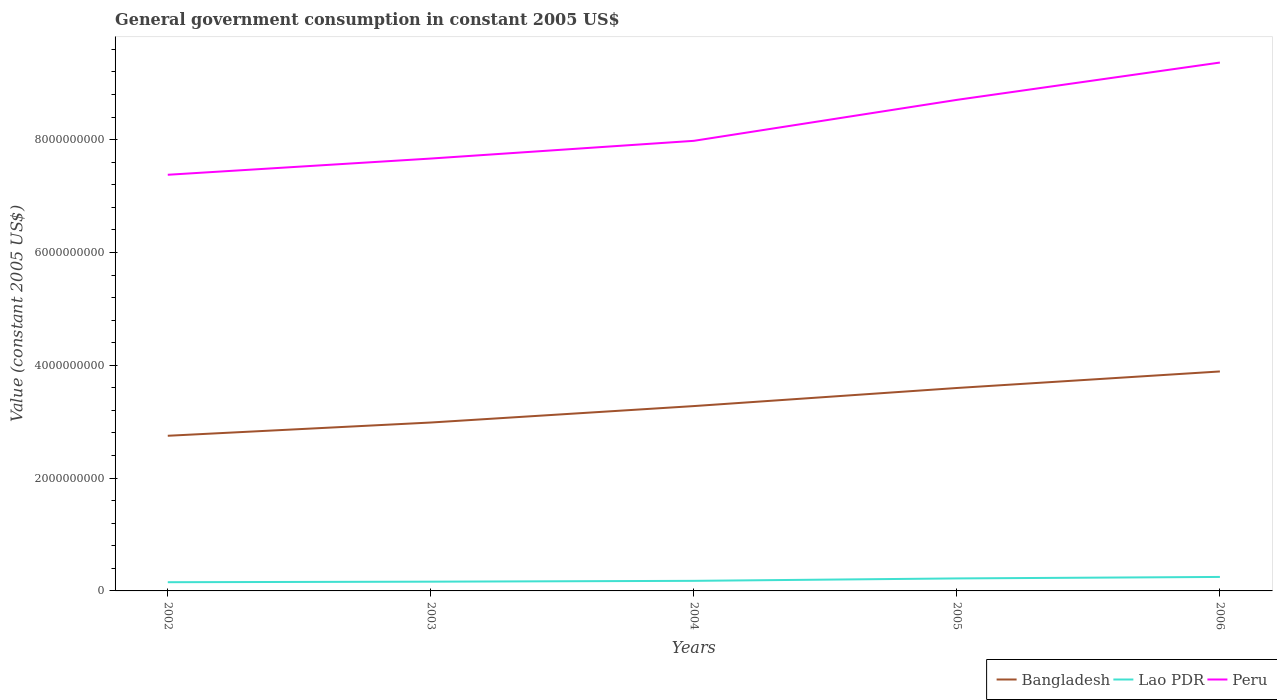Does the line corresponding to Lao PDR intersect with the line corresponding to Bangladesh?
Keep it short and to the point. No. Across all years, what is the maximum government conusmption in Peru?
Give a very brief answer. 7.38e+09. What is the total government conusmption in Bangladesh in the graph?
Provide a succinct answer. -2.35e+08. What is the difference between the highest and the second highest government conusmption in Bangladesh?
Offer a very short reply. 1.14e+09. What is the difference between the highest and the lowest government conusmption in Bangladesh?
Make the answer very short. 2. How many lines are there?
Make the answer very short. 3. What is the difference between two consecutive major ticks on the Y-axis?
Give a very brief answer. 2.00e+09. Are the values on the major ticks of Y-axis written in scientific E-notation?
Ensure brevity in your answer.  No. How many legend labels are there?
Provide a short and direct response. 3. How are the legend labels stacked?
Make the answer very short. Horizontal. What is the title of the graph?
Ensure brevity in your answer.  General government consumption in constant 2005 US$. Does "India" appear as one of the legend labels in the graph?
Your answer should be very brief. No. What is the label or title of the Y-axis?
Ensure brevity in your answer.  Value (constant 2005 US$). What is the Value (constant 2005 US$) in Bangladesh in 2002?
Offer a very short reply. 2.75e+09. What is the Value (constant 2005 US$) in Lao PDR in 2002?
Offer a very short reply. 1.55e+08. What is the Value (constant 2005 US$) in Peru in 2002?
Give a very brief answer. 7.38e+09. What is the Value (constant 2005 US$) of Bangladesh in 2003?
Make the answer very short. 2.99e+09. What is the Value (constant 2005 US$) in Lao PDR in 2003?
Your response must be concise. 1.64e+08. What is the Value (constant 2005 US$) of Peru in 2003?
Keep it short and to the point. 7.66e+09. What is the Value (constant 2005 US$) in Bangladesh in 2004?
Provide a short and direct response. 3.28e+09. What is the Value (constant 2005 US$) in Lao PDR in 2004?
Keep it short and to the point. 1.79e+08. What is the Value (constant 2005 US$) of Peru in 2004?
Your answer should be compact. 7.98e+09. What is the Value (constant 2005 US$) in Bangladesh in 2005?
Offer a terse response. 3.60e+09. What is the Value (constant 2005 US$) of Lao PDR in 2005?
Offer a terse response. 2.22e+08. What is the Value (constant 2005 US$) of Peru in 2005?
Your answer should be very brief. 8.70e+09. What is the Value (constant 2005 US$) in Bangladesh in 2006?
Offer a terse response. 3.89e+09. What is the Value (constant 2005 US$) in Lao PDR in 2006?
Your answer should be compact. 2.48e+08. What is the Value (constant 2005 US$) of Peru in 2006?
Make the answer very short. 9.37e+09. Across all years, what is the maximum Value (constant 2005 US$) in Bangladesh?
Make the answer very short. 3.89e+09. Across all years, what is the maximum Value (constant 2005 US$) of Lao PDR?
Give a very brief answer. 2.48e+08. Across all years, what is the maximum Value (constant 2005 US$) in Peru?
Your answer should be compact. 9.37e+09. Across all years, what is the minimum Value (constant 2005 US$) of Bangladesh?
Offer a very short reply. 2.75e+09. Across all years, what is the minimum Value (constant 2005 US$) in Lao PDR?
Keep it short and to the point. 1.55e+08. Across all years, what is the minimum Value (constant 2005 US$) in Peru?
Your answer should be compact. 7.38e+09. What is the total Value (constant 2005 US$) of Bangladesh in the graph?
Your answer should be compact. 1.65e+1. What is the total Value (constant 2005 US$) of Lao PDR in the graph?
Provide a short and direct response. 9.67e+08. What is the total Value (constant 2005 US$) in Peru in the graph?
Make the answer very short. 4.11e+1. What is the difference between the Value (constant 2005 US$) in Bangladesh in 2002 and that in 2003?
Give a very brief answer. -2.35e+08. What is the difference between the Value (constant 2005 US$) in Lao PDR in 2002 and that in 2003?
Provide a succinct answer. -9.44e+06. What is the difference between the Value (constant 2005 US$) of Peru in 2002 and that in 2003?
Make the answer very short. -2.88e+08. What is the difference between the Value (constant 2005 US$) in Bangladesh in 2002 and that in 2004?
Offer a very short reply. -5.26e+08. What is the difference between the Value (constant 2005 US$) of Lao PDR in 2002 and that in 2004?
Your answer should be compact. -2.40e+07. What is the difference between the Value (constant 2005 US$) of Peru in 2002 and that in 2004?
Your response must be concise. -6.02e+08. What is the difference between the Value (constant 2005 US$) in Bangladesh in 2002 and that in 2005?
Provide a short and direct response. -8.47e+08. What is the difference between the Value (constant 2005 US$) of Lao PDR in 2002 and that in 2005?
Offer a very short reply. -6.69e+07. What is the difference between the Value (constant 2005 US$) of Peru in 2002 and that in 2005?
Provide a succinct answer. -1.33e+09. What is the difference between the Value (constant 2005 US$) in Bangladesh in 2002 and that in 2006?
Your answer should be compact. -1.14e+09. What is the difference between the Value (constant 2005 US$) in Lao PDR in 2002 and that in 2006?
Provide a short and direct response. -9.34e+07. What is the difference between the Value (constant 2005 US$) in Peru in 2002 and that in 2006?
Your answer should be very brief. -1.99e+09. What is the difference between the Value (constant 2005 US$) in Bangladesh in 2003 and that in 2004?
Offer a very short reply. -2.91e+08. What is the difference between the Value (constant 2005 US$) of Lao PDR in 2003 and that in 2004?
Provide a succinct answer. -1.46e+07. What is the difference between the Value (constant 2005 US$) in Peru in 2003 and that in 2004?
Keep it short and to the point. -3.14e+08. What is the difference between the Value (constant 2005 US$) in Bangladesh in 2003 and that in 2005?
Provide a short and direct response. -6.12e+08. What is the difference between the Value (constant 2005 US$) in Lao PDR in 2003 and that in 2005?
Your answer should be very brief. -5.75e+07. What is the difference between the Value (constant 2005 US$) in Peru in 2003 and that in 2005?
Provide a short and direct response. -1.04e+09. What is the difference between the Value (constant 2005 US$) in Bangladesh in 2003 and that in 2006?
Your answer should be very brief. -9.05e+08. What is the difference between the Value (constant 2005 US$) in Lao PDR in 2003 and that in 2006?
Give a very brief answer. -8.39e+07. What is the difference between the Value (constant 2005 US$) of Peru in 2003 and that in 2006?
Your response must be concise. -1.70e+09. What is the difference between the Value (constant 2005 US$) in Bangladesh in 2004 and that in 2005?
Your response must be concise. -3.21e+08. What is the difference between the Value (constant 2005 US$) in Lao PDR in 2004 and that in 2005?
Your response must be concise. -4.29e+07. What is the difference between the Value (constant 2005 US$) of Peru in 2004 and that in 2005?
Your answer should be very brief. -7.26e+08. What is the difference between the Value (constant 2005 US$) of Bangladesh in 2004 and that in 2006?
Provide a succinct answer. -6.14e+08. What is the difference between the Value (constant 2005 US$) of Lao PDR in 2004 and that in 2006?
Keep it short and to the point. -6.93e+07. What is the difference between the Value (constant 2005 US$) in Peru in 2004 and that in 2006?
Give a very brief answer. -1.39e+09. What is the difference between the Value (constant 2005 US$) in Bangladesh in 2005 and that in 2006?
Provide a succinct answer. -2.93e+08. What is the difference between the Value (constant 2005 US$) of Lao PDR in 2005 and that in 2006?
Offer a very short reply. -2.64e+07. What is the difference between the Value (constant 2005 US$) of Peru in 2005 and that in 2006?
Ensure brevity in your answer.  -6.61e+08. What is the difference between the Value (constant 2005 US$) of Bangladesh in 2002 and the Value (constant 2005 US$) of Lao PDR in 2003?
Offer a terse response. 2.59e+09. What is the difference between the Value (constant 2005 US$) in Bangladesh in 2002 and the Value (constant 2005 US$) in Peru in 2003?
Provide a short and direct response. -4.91e+09. What is the difference between the Value (constant 2005 US$) in Lao PDR in 2002 and the Value (constant 2005 US$) in Peru in 2003?
Offer a very short reply. -7.51e+09. What is the difference between the Value (constant 2005 US$) in Bangladesh in 2002 and the Value (constant 2005 US$) in Lao PDR in 2004?
Give a very brief answer. 2.57e+09. What is the difference between the Value (constant 2005 US$) in Bangladesh in 2002 and the Value (constant 2005 US$) in Peru in 2004?
Provide a succinct answer. -5.23e+09. What is the difference between the Value (constant 2005 US$) in Lao PDR in 2002 and the Value (constant 2005 US$) in Peru in 2004?
Offer a terse response. -7.82e+09. What is the difference between the Value (constant 2005 US$) in Bangladesh in 2002 and the Value (constant 2005 US$) in Lao PDR in 2005?
Keep it short and to the point. 2.53e+09. What is the difference between the Value (constant 2005 US$) of Bangladesh in 2002 and the Value (constant 2005 US$) of Peru in 2005?
Offer a very short reply. -5.95e+09. What is the difference between the Value (constant 2005 US$) in Lao PDR in 2002 and the Value (constant 2005 US$) in Peru in 2005?
Make the answer very short. -8.55e+09. What is the difference between the Value (constant 2005 US$) in Bangladesh in 2002 and the Value (constant 2005 US$) in Lao PDR in 2006?
Your answer should be very brief. 2.50e+09. What is the difference between the Value (constant 2005 US$) in Bangladesh in 2002 and the Value (constant 2005 US$) in Peru in 2006?
Provide a succinct answer. -6.62e+09. What is the difference between the Value (constant 2005 US$) in Lao PDR in 2002 and the Value (constant 2005 US$) in Peru in 2006?
Keep it short and to the point. -9.21e+09. What is the difference between the Value (constant 2005 US$) of Bangladesh in 2003 and the Value (constant 2005 US$) of Lao PDR in 2004?
Provide a succinct answer. 2.81e+09. What is the difference between the Value (constant 2005 US$) of Bangladesh in 2003 and the Value (constant 2005 US$) of Peru in 2004?
Your answer should be compact. -4.99e+09. What is the difference between the Value (constant 2005 US$) of Lao PDR in 2003 and the Value (constant 2005 US$) of Peru in 2004?
Provide a short and direct response. -7.81e+09. What is the difference between the Value (constant 2005 US$) in Bangladesh in 2003 and the Value (constant 2005 US$) in Lao PDR in 2005?
Offer a terse response. 2.76e+09. What is the difference between the Value (constant 2005 US$) of Bangladesh in 2003 and the Value (constant 2005 US$) of Peru in 2005?
Your answer should be very brief. -5.72e+09. What is the difference between the Value (constant 2005 US$) in Lao PDR in 2003 and the Value (constant 2005 US$) in Peru in 2005?
Keep it short and to the point. -8.54e+09. What is the difference between the Value (constant 2005 US$) in Bangladesh in 2003 and the Value (constant 2005 US$) in Lao PDR in 2006?
Your response must be concise. 2.74e+09. What is the difference between the Value (constant 2005 US$) of Bangladesh in 2003 and the Value (constant 2005 US$) of Peru in 2006?
Offer a terse response. -6.38e+09. What is the difference between the Value (constant 2005 US$) in Lao PDR in 2003 and the Value (constant 2005 US$) in Peru in 2006?
Offer a very short reply. -9.20e+09. What is the difference between the Value (constant 2005 US$) of Bangladesh in 2004 and the Value (constant 2005 US$) of Lao PDR in 2005?
Offer a terse response. 3.06e+09. What is the difference between the Value (constant 2005 US$) in Bangladesh in 2004 and the Value (constant 2005 US$) in Peru in 2005?
Give a very brief answer. -5.43e+09. What is the difference between the Value (constant 2005 US$) in Lao PDR in 2004 and the Value (constant 2005 US$) in Peru in 2005?
Your response must be concise. -8.53e+09. What is the difference between the Value (constant 2005 US$) in Bangladesh in 2004 and the Value (constant 2005 US$) in Lao PDR in 2006?
Your answer should be compact. 3.03e+09. What is the difference between the Value (constant 2005 US$) of Bangladesh in 2004 and the Value (constant 2005 US$) of Peru in 2006?
Your answer should be very brief. -6.09e+09. What is the difference between the Value (constant 2005 US$) in Lao PDR in 2004 and the Value (constant 2005 US$) in Peru in 2006?
Your answer should be compact. -9.19e+09. What is the difference between the Value (constant 2005 US$) in Bangladesh in 2005 and the Value (constant 2005 US$) in Lao PDR in 2006?
Offer a very short reply. 3.35e+09. What is the difference between the Value (constant 2005 US$) in Bangladesh in 2005 and the Value (constant 2005 US$) in Peru in 2006?
Your response must be concise. -5.77e+09. What is the difference between the Value (constant 2005 US$) of Lao PDR in 2005 and the Value (constant 2005 US$) of Peru in 2006?
Your answer should be very brief. -9.14e+09. What is the average Value (constant 2005 US$) of Bangladesh per year?
Ensure brevity in your answer.  3.30e+09. What is the average Value (constant 2005 US$) in Lao PDR per year?
Your answer should be compact. 1.93e+08. What is the average Value (constant 2005 US$) in Peru per year?
Your response must be concise. 8.22e+09. In the year 2002, what is the difference between the Value (constant 2005 US$) in Bangladesh and Value (constant 2005 US$) in Lao PDR?
Your answer should be very brief. 2.60e+09. In the year 2002, what is the difference between the Value (constant 2005 US$) of Bangladesh and Value (constant 2005 US$) of Peru?
Provide a short and direct response. -4.63e+09. In the year 2002, what is the difference between the Value (constant 2005 US$) of Lao PDR and Value (constant 2005 US$) of Peru?
Provide a succinct answer. -7.22e+09. In the year 2003, what is the difference between the Value (constant 2005 US$) in Bangladesh and Value (constant 2005 US$) in Lao PDR?
Your response must be concise. 2.82e+09. In the year 2003, what is the difference between the Value (constant 2005 US$) of Bangladesh and Value (constant 2005 US$) of Peru?
Offer a very short reply. -4.68e+09. In the year 2003, what is the difference between the Value (constant 2005 US$) of Lao PDR and Value (constant 2005 US$) of Peru?
Keep it short and to the point. -7.50e+09. In the year 2004, what is the difference between the Value (constant 2005 US$) of Bangladesh and Value (constant 2005 US$) of Lao PDR?
Provide a short and direct response. 3.10e+09. In the year 2004, what is the difference between the Value (constant 2005 US$) of Bangladesh and Value (constant 2005 US$) of Peru?
Give a very brief answer. -4.70e+09. In the year 2004, what is the difference between the Value (constant 2005 US$) in Lao PDR and Value (constant 2005 US$) in Peru?
Provide a succinct answer. -7.80e+09. In the year 2005, what is the difference between the Value (constant 2005 US$) of Bangladesh and Value (constant 2005 US$) of Lao PDR?
Offer a very short reply. 3.38e+09. In the year 2005, what is the difference between the Value (constant 2005 US$) of Bangladesh and Value (constant 2005 US$) of Peru?
Keep it short and to the point. -5.11e+09. In the year 2005, what is the difference between the Value (constant 2005 US$) of Lao PDR and Value (constant 2005 US$) of Peru?
Offer a very short reply. -8.48e+09. In the year 2006, what is the difference between the Value (constant 2005 US$) in Bangladesh and Value (constant 2005 US$) in Lao PDR?
Provide a succinct answer. 3.64e+09. In the year 2006, what is the difference between the Value (constant 2005 US$) in Bangladesh and Value (constant 2005 US$) in Peru?
Offer a very short reply. -5.48e+09. In the year 2006, what is the difference between the Value (constant 2005 US$) of Lao PDR and Value (constant 2005 US$) of Peru?
Give a very brief answer. -9.12e+09. What is the ratio of the Value (constant 2005 US$) of Bangladesh in 2002 to that in 2003?
Keep it short and to the point. 0.92. What is the ratio of the Value (constant 2005 US$) of Lao PDR in 2002 to that in 2003?
Your response must be concise. 0.94. What is the ratio of the Value (constant 2005 US$) of Peru in 2002 to that in 2003?
Ensure brevity in your answer.  0.96. What is the ratio of the Value (constant 2005 US$) of Bangladesh in 2002 to that in 2004?
Keep it short and to the point. 0.84. What is the ratio of the Value (constant 2005 US$) of Lao PDR in 2002 to that in 2004?
Your answer should be very brief. 0.87. What is the ratio of the Value (constant 2005 US$) in Peru in 2002 to that in 2004?
Give a very brief answer. 0.92. What is the ratio of the Value (constant 2005 US$) in Bangladesh in 2002 to that in 2005?
Offer a very short reply. 0.76. What is the ratio of the Value (constant 2005 US$) in Lao PDR in 2002 to that in 2005?
Offer a very short reply. 0.7. What is the ratio of the Value (constant 2005 US$) in Peru in 2002 to that in 2005?
Give a very brief answer. 0.85. What is the ratio of the Value (constant 2005 US$) in Bangladesh in 2002 to that in 2006?
Offer a terse response. 0.71. What is the ratio of the Value (constant 2005 US$) of Lao PDR in 2002 to that in 2006?
Offer a very short reply. 0.62. What is the ratio of the Value (constant 2005 US$) of Peru in 2002 to that in 2006?
Offer a terse response. 0.79. What is the ratio of the Value (constant 2005 US$) of Bangladesh in 2003 to that in 2004?
Make the answer very short. 0.91. What is the ratio of the Value (constant 2005 US$) of Lao PDR in 2003 to that in 2004?
Your response must be concise. 0.92. What is the ratio of the Value (constant 2005 US$) of Peru in 2003 to that in 2004?
Give a very brief answer. 0.96. What is the ratio of the Value (constant 2005 US$) of Bangladesh in 2003 to that in 2005?
Provide a short and direct response. 0.83. What is the ratio of the Value (constant 2005 US$) in Lao PDR in 2003 to that in 2005?
Offer a very short reply. 0.74. What is the ratio of the Value (constant 2005 US$) of Peru in 2003 to that in 2005?
Provide a short and direct response. 0.88. What is the ratio of the Value (constant 2005 US$) of Bangladesh in 2003 to that in 2006?
Your response must be concise. 0.77. What is the ratio of the Value (constant 2005 US$) of Lao PDR in 2003 to that in 2006?
Your answer should be compact. 0.66. What is the ratio of the Value (constant 2005 US$) in Peru in 2003 to that in 2006?
Make the answer very short. 0.82. What is the ratio of the Value (constant 2005 US$) of Bangladesh in 2004 to that in 2005?
Make the answer very short. 0.91. What is the ratio of the Value (constant 2005 US$) of Lao PDR in 2004 to that in 2005?
Provide a succinct answer. 0.81. What is the ratio of the Value (constant 2005 US$) in Peru in 2004 to that in 2005?
Your response must be concise. 0.92. What is the ratio of the Value (constant 2005 US$) of Bangladesh in 2004 to that in 2006?
Give a very brief answer. 0.84. What is the ratio of the Value (constant 2005 US$) in Lao PDR in 2004 to that in 2006?
Provide a short and direct response. 0.72. What is the ratio of the Value (constant 2005 US$) in Peru in 2004 to that in 2006?
Your answer should be very brief. 0.85. What is the ratio of the Value (constant 2005 US$) in Bangladesh in 2005 to that in 2006?
Provide a succinct answer. 0.92. What is the ratio of the Value (constant 2005 US$) in Lao PDR in 2005 to that in 2006?
Your answer should be compact. 0.89. What is the ratio of the Value (constant 2005 US$) of Peru in 2005 to that in 2006?
Offer a very short reply. 0.93. What is the difference between the highest and the second highest Value (constant 2005 US$) of Bangladesh?
Give a very brief answer. 2.93e+08. What is the difference between the highest and the second highest Value (constant 2005 US$) in Lao PDR?
Ensure brevity in your answer.  2.64e+07. What is the difference between the highest and the second highest Value (constant 2005 US$) in Peru?
Your answer should be compact. 6.61e+08. What is the difference between the highest and the lowest Value (constant 2005 US$) of Bangladesh?
Your response must be concise. 1.14e+09. What is the difference between the highest and the lowest Value (constant 2005 US$) in Lao PDR?
Your answer should be compact. 9.34e+07. What is the difference between the highest and the lowest Value (constant 2005 US$) in Peru?
Provide a short and direct response. 1.99e+09. 